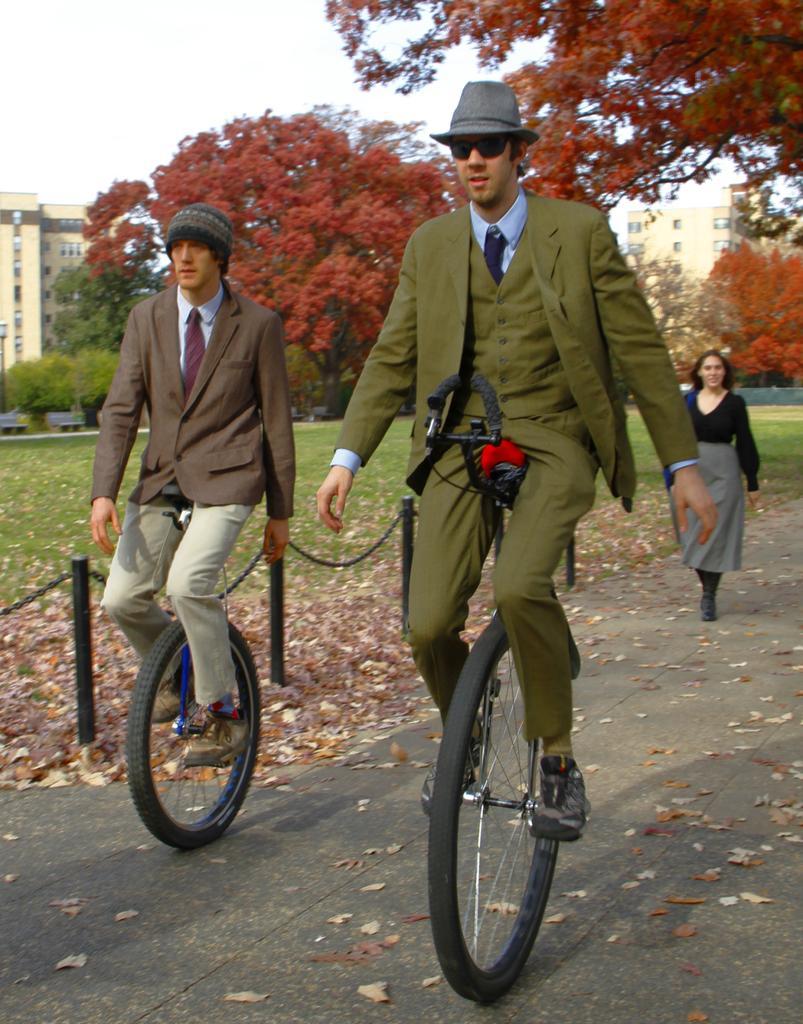Describe this image in one or two sentences. In this image, we can see two persons wearing clothes and riding bikes on the road. There is an another person on the right side of the image. There are poles on the left side of the image. In the background of the image, there are some trees and buildings. 